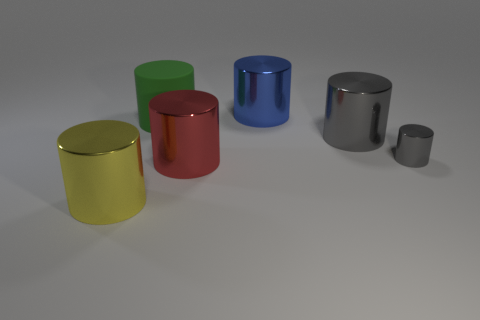There is a gray cylinder that is in front of the large gray cylinder behind the red metallic thing; how big is it?
Offer a very short reply. Small. How many large things are shiny cylinders or green things?
Keep it short and to the point. 5. There is a gray metallic object that is in front of the large object that is on the right side of the big shiny cylinder that is behind the big rubber cylinder; how big is it?
Offer a terse response. Small. Is there any other thing of the same color as the small object?
Offer a very short reply. Yes. The big object that is on the right side of the cylinder that is behind the big green rubber thing left of the red shiny cylinder is made of what material?
Your answer should be very brief. Metal. Do the green matte thing and the yellow thing have the same shape?
Ensure brevity in your answer.  Yes. Is there anything else that has the same material as the green cylinder?
Your answer should be compact. No. What number of metallic cylinders are behind the yellow metal cylinder and to the left of the tiny gray cylinder?
Offer a terse response. 3. What color is the metallic thing to the right of the gray object behind the tiny gray cylinder?
Ensure brevity in your answer.  Gray. Are there the same number of tiny things that are left of the large green cylinder and large gray rubber objects?
Provide a succinct answer. Yes. 